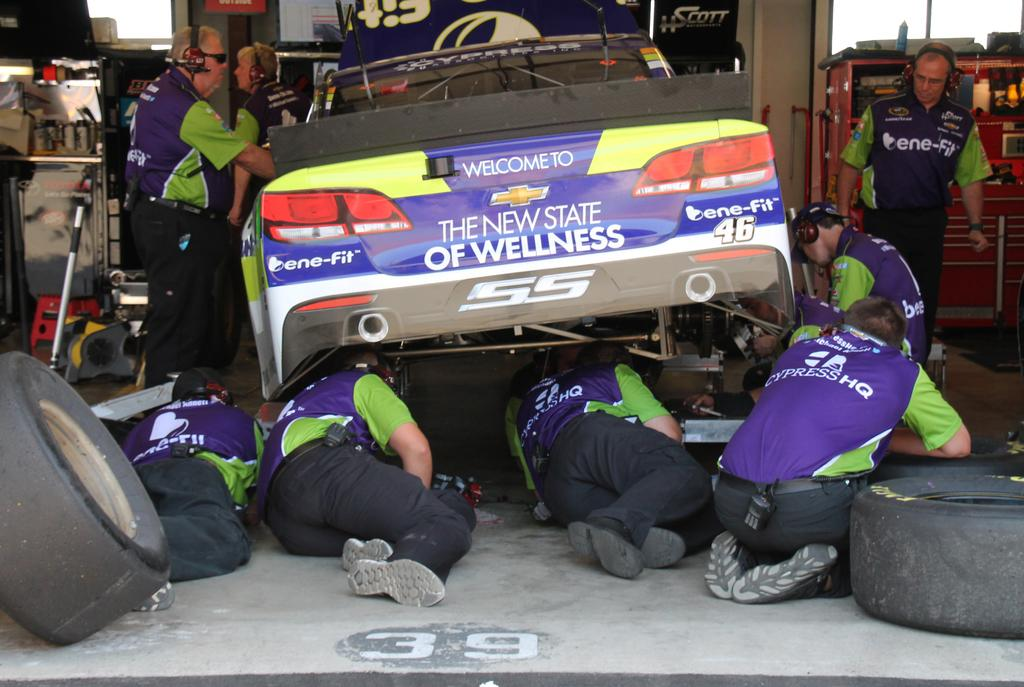What are the people in the foreground of the image doing? The people in the foreground of the image are lying on the floor. What is happening in the background of the image? There are people working in the background, and there is a car, tires, and instruments visible. How many people can be seen working in the background? There are three persons working in the background. What type of canvas is being used by the people in the image? There is no canvas present in the image; it features people lying on the floor and working in the background. How many clocks can be seen in the image? There are no clocks visible in the image. 